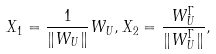Convert formula to latex. <formula><loc_0><loc_0><loc_500><loc_500>X _ { 1 } = \frac { 1 } { \| W _ { U } \| } W _ { U } , X _ { 2 } = \frac { W _ { U } ^ { \Gamma } } { \| W _ { U } ^ { \Gamma } \| } ,</formula> 